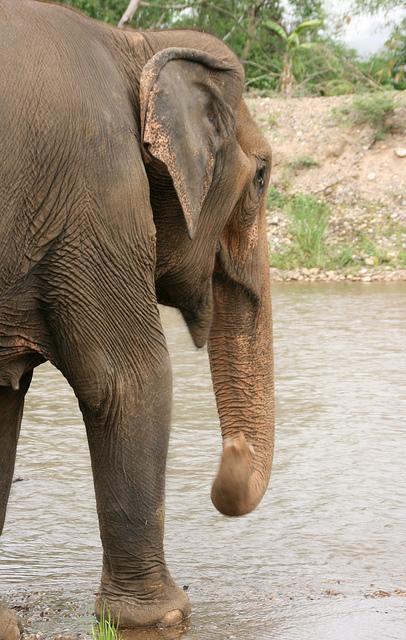Is there a baby elephant in the picture?
Short answer required. No. Is the elephant at a zoo?
Short answer required. Yes. Which of the elephant's ears is visible?
Keep it brief. Right. How many legs can you see?
Keep it brief. 2. Is the elephant hungry?
Short answer required. No. Is this elephant in the wild?
Give a very brief answer. No. Is the elephant old?
Short answer required. Yes. 